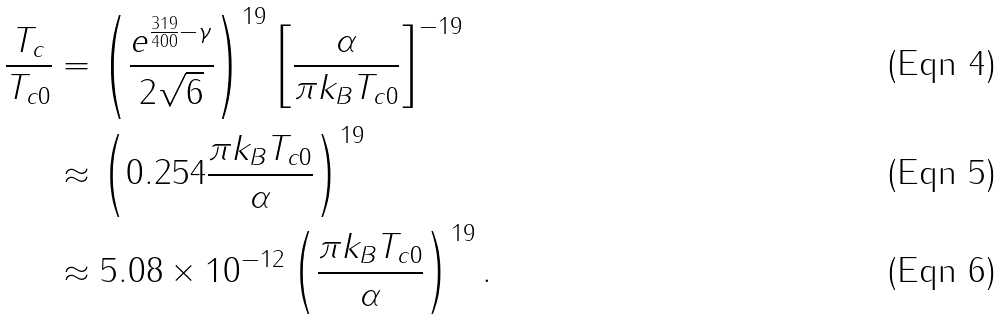Convert formula to latex. <formula><loc_0><loc_0><loc_500><loc_500>\frac { T _ { c } } { T _ { c 0 } } & = \left ( \frac { e ^ { \frac { 3 1 9 } { 4 0 0 } - \gamma } } { 2 \sqrt { 6 } } \right ) ^ { 1 9 } \left [ \frac { \alpha } { \pi k _ { B } T _ { c 0 } } \right ] ^ { - 1 9 } \\ & \approx \left ( 0 . 2 5 4 \frac { \pi k _ { B } T _ { c 0 } } { \alpha } \right ) ^ { 1 9 } \\ & \approx 5 . 0 8 \times 1 0 ^ { - 1 2 } \left ( \frac { \pi k _ { B } T _ { c 0 } } { \alpha } \right ) ^ { 1 9 } .</formula> 